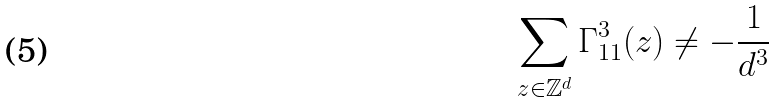<formula> <loc_0><loc_0><loc_500><loc_500>\sum _ { z \in { \mathbb { Z } } ^ { d } } \Gamma _ { 1 1 } ^ { 3 } ( z ) \neq - \frac { 1 } { d ^ { 3 } }</formula> 